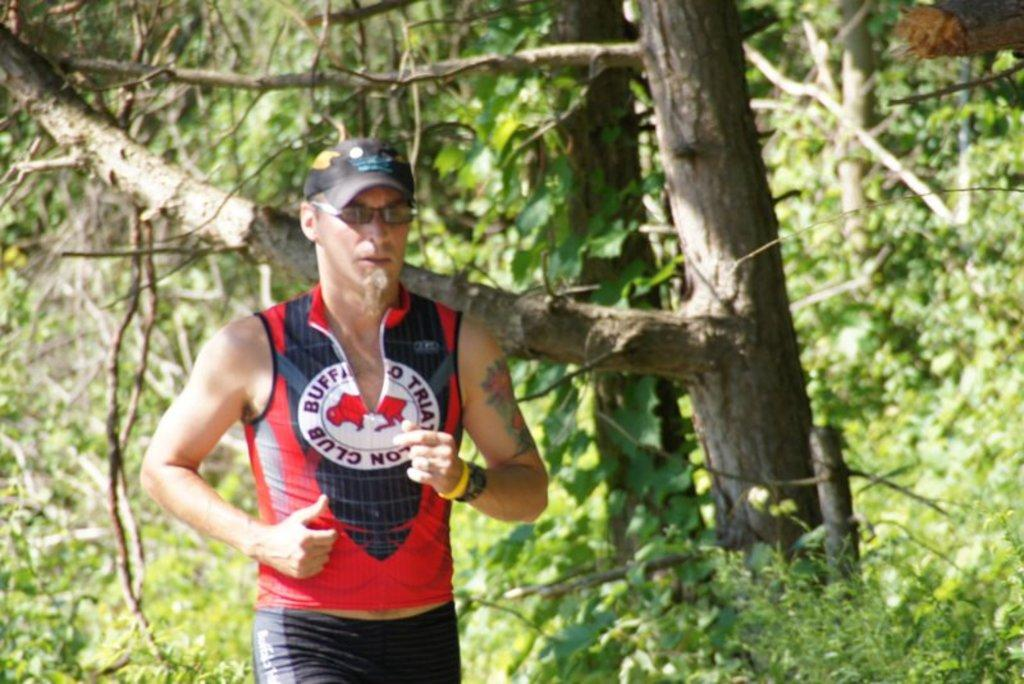<image>
Summarize the visual content of the image. A man jogging near some trees wearing a red and black buffalos shirt. 